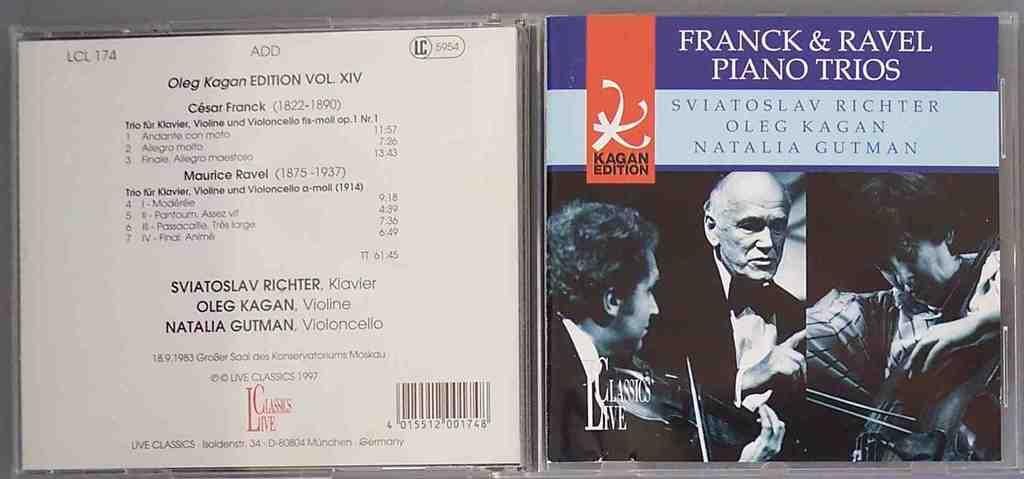Who plays the piano in this record?
Provide a succinct answer. Franck & ravel. 